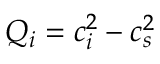<formula> <loc_0><loc_0><loc_500><loc_500>Q _ { i } = c _ { i } ^ { 2 } - c _ { s } ^ { 2 }</formula> 